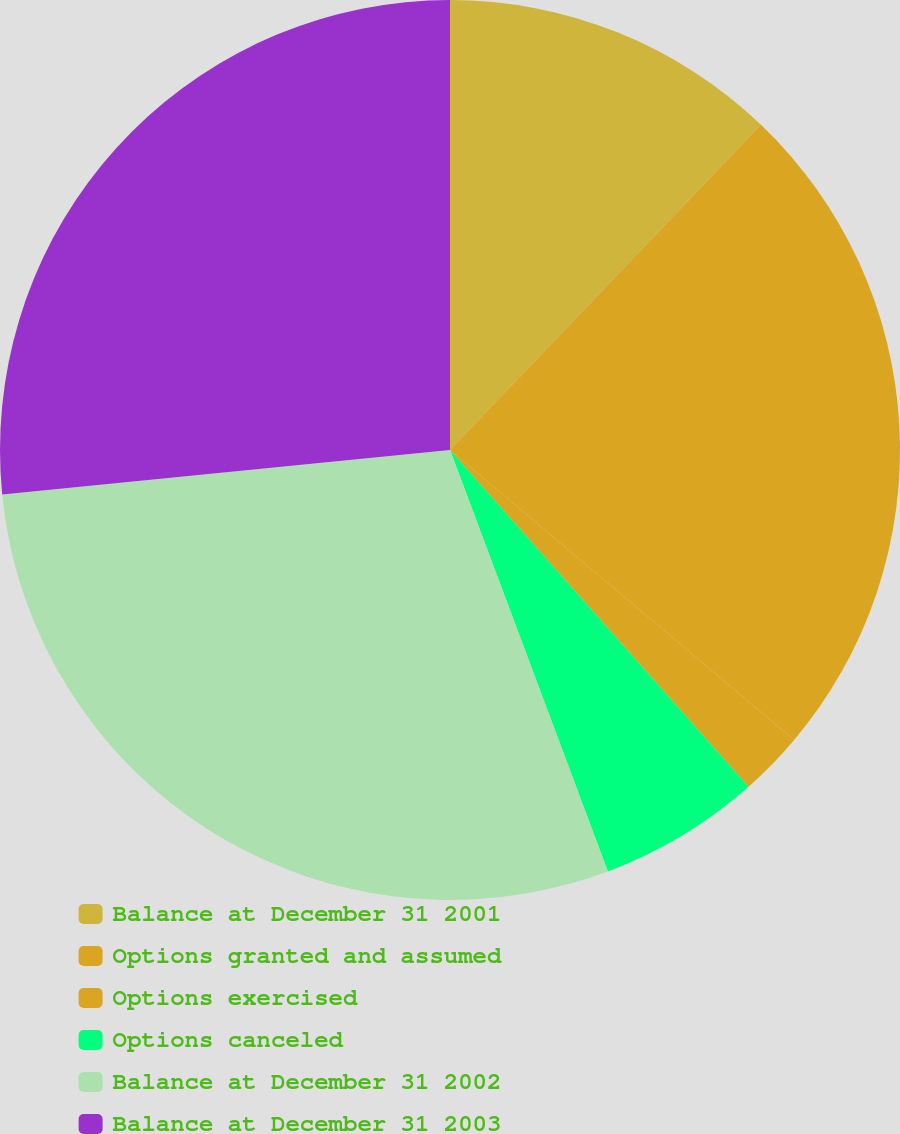<chart> <loc_0><loc_0><loc_500><loc_500><pie_chart><fcel>Balance at December 31 2001<fcel>Options granted and assumed<fcel>Options exercised<fcel>Options canceled<fcel>Balance at December 31 2002<fcel>Balance at December 31 2003<nl><fcel>12.14%<fcel>24.0%<fcel>2.31%<fcel>5.84%<fcel>29.13%<fcel>26.57%<nl></chart> 